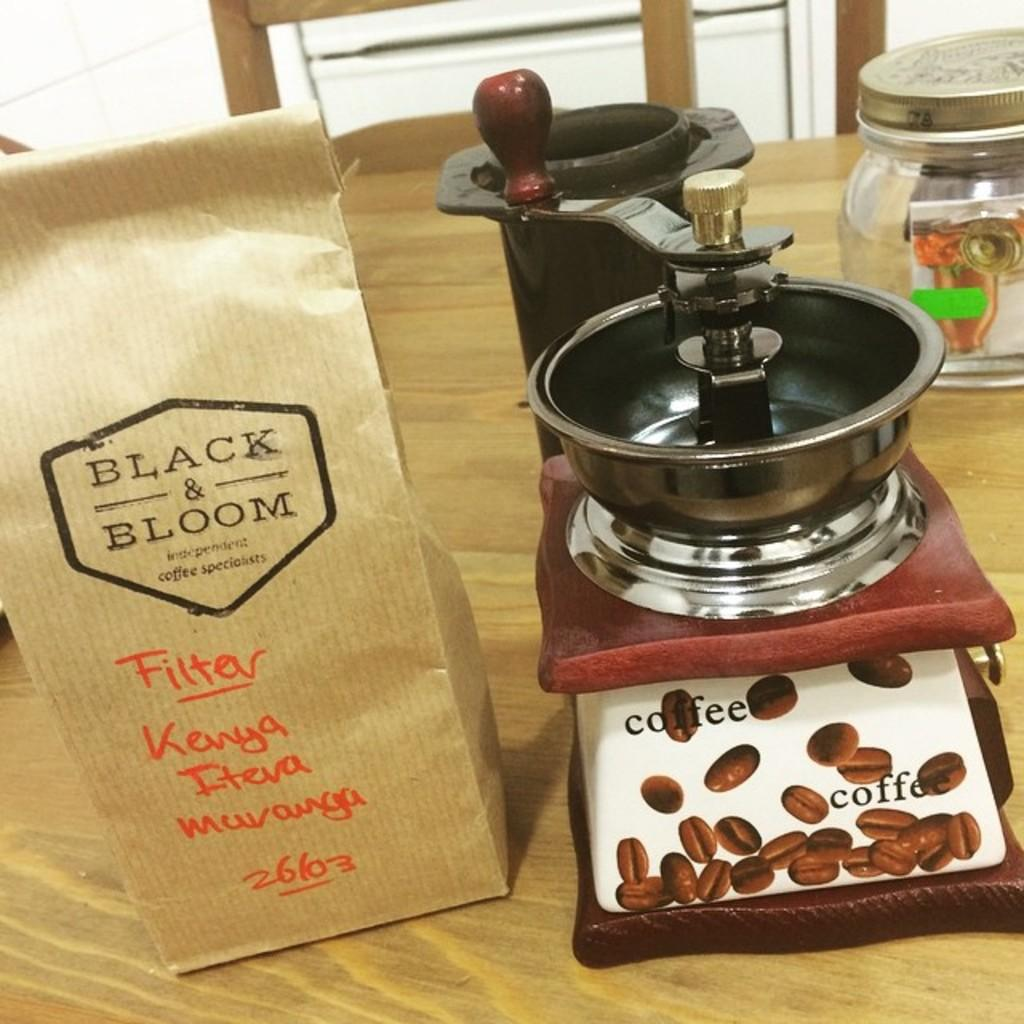<image>
Provide a brief description of the given image. A brown bag of Black & Bloom coffee sits on a table. 